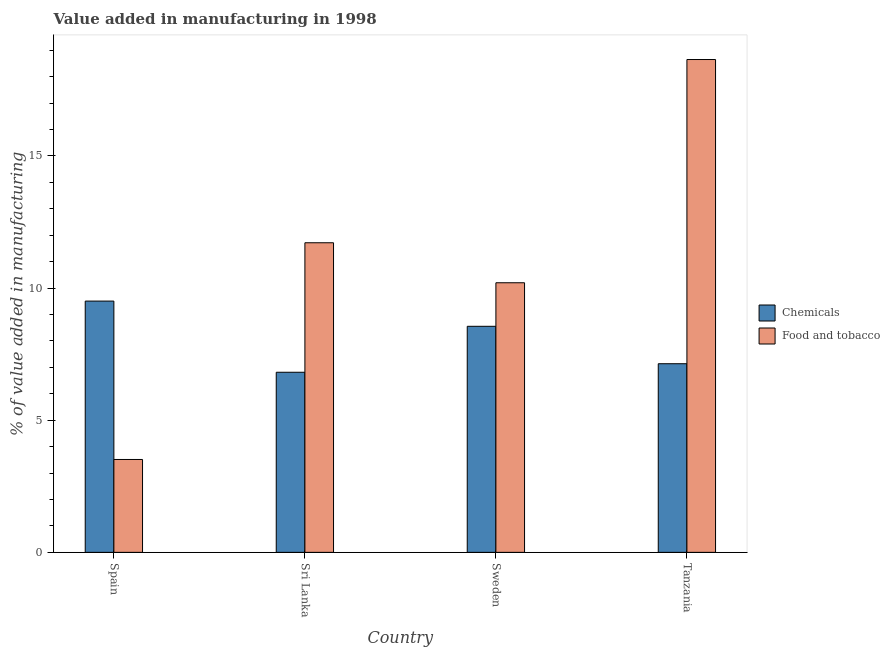How many different coloured bars are there?
Make the answer very short. 2. Are the number of bars per tick equal to the number of legend labels?
Offer a very short reply. Yes. How many bars are there on the 4th tick from the left?
Keep it short and to the point. 2. What is the label of the 3rd group of bars from the left?
Offer a terse response. Sweden. What is the value added by manufacturing food and tobacco in Tanzania?
Your response must be concise. 18.65. Across all countries, what is the maximum value added by manufacturing food and tobacco?
Provide a succinct answer. 18.65. Across all countries, what is the minimum value added by  manufacturing chemicals?
Provide a short and direct response. 6.81. In which country was the value added by  manufacturing chemicals maximum?
Offer a very short reply. Spain. In which country was the value added by  manufacturing chemicals minimum?
Make the answer very short. Sri Lanka. What is the total value added by  manufacturing chemicals in the graph?
Your answer should be compact. 32.01. What is the difference between the value added by manufacturing food and tobacco in Spain and that in Sweden?
Offer a terse response. -6.69. What is the difference between the value added by  manufacturing chemicals in Sweden and the value added by manufacturing food and tobacco in Tanzania?
Make the answer very short. -10.09. What is the average value added by  manufacturing chemicals per country?
Offer a terse response. 8. What is the difference between the value added by  manufacturing chemicals and value added by manufacturing food and tobacco in Tanzania?
Offer a terse response. -11.51. In how many countries, is the value added by  manufacturing chemicals greater than 14 %?
Make the answer very short. 0. What is the ratio of the value added by manufacturing food and tobacco in Sweden to that in Tanzania?
Ensure brevity in your answer.  0.55. Is the difference between the value added by manufacturing food and tobacco in Sweden and Tanzania greater than the difference between the value added by  manufacturing chemicals in Sweden and Tanzania?
Offer a terse response. No. What is the difference between the highest and the second highest value added by  manufacturing chemicals?
Provide a succinct answer. 0.95. What is the difference between the highest and the lowest value added by manufacturing food and tobacco?
Make the answer very short. 15.13. What does the 1st bar from the left in Sri Lanka represents?
Offer a very short reply. Chemicals. What does the 1st bar from the right in Sweden represents?
Your answer should be compact. Food and tobacco. How many bars are there?
Keep it short and to the point. 8. What is the difference between two consecutive major ticks on the Y-axis?
Keep it short and to the point. 5. Does the graph contain any zero values?
Provide a short and direct response. No. How many legend labels are there?
Your answer should be compact. 2. What is the title of the graph?
Ensure brevity in your answer.  Value added in manufacturing in 1998. What is the label or title of the Y-axis?
Provide a succinct answer. % of value added in manufacturing. What is the % of value added in manufacturing of Chemicals in Spain?
Your answer should be compact. 9.51. What is the % of value added in manufacturing in Food and tobacco in Spain?
Provide a succinct answer. 3.51. What is the % of value added in manufacturing of Chemicals in Sri Lanka?
Ensure brevity in your answer.  6.81. What is the % of value added in manufacturing in Food and tobacco in Sri Lanka?
Your answer should be compact. 11.71. What is the % of value added in manufacturing in Chemicals in Sweden?
Provide a short and direct response. 8.55. What is the % of value added in manufacturing of Food and tobacco in Sweden?
Ensure brevity in your answer.  10.2. What is the % of value added in manufacturing in Chemicals in Tanzania?
Your answer should be compact. 7.14. What is the % of value added in manufacturing of Food and tobacco in Tanzania?
Keep it short and to the point. 18.65. Across all countries, what is the maximum % of value added in manufacturing in Chemicals?
Offer a very short reply. 9.51. Across all countries, what is the maximum % of value added in manufacturing of Food and tobacco?
Your response must be concise. 18.65. Across all countries, what is the minimum % of value added in manufacturing of Chemicals?
Keep it short and to the point. 6.81. Across all countries, what is the minimum % of value added in manufacturing of Food and tobacco?
Keep it short and to the point. 3.51. What is the total % of value added in manufacturing of Chemicals in the graph?
Provide a short and direct response. 32.01. What is the total % of value added in manufacturing of Food and tobacco in the graph?
Your response must be concise. 44.08. What is the difference between the % of value added in manufacturing in Chemicals in Spain and that in Sri Lanka?
Provide a succinct answer. 2.69. What is the difference between the % of value added in manufacturing in Food and tobacco in Spain and that in Sri Lanka?
Your response must be concise. -8.2. What is the difference between the % of value added in manufacturing of Chemicals in Spain and that in Sweden?
Make the answer very short. 0.95. What is the difference between the % of value added in manufacturing of Food and tobacco in Spain and that in Sweden?
Your answer should be very brief. -6.69. What is the difference between the % of value added in manufacturing of Chemicals in Spain and that in Tanzania?
Offer a very short reply. 2.37. What is the difference between the % of value added in manufacturing in Food and tobacco in Spain and that in Tanzania?
Your answer should be very brief. -15.13. What is the difference between the % of value added in manufacturing of Chemicals in Sri Lanka and that in Sweden?
Offer a terse response. -1.74. What is the difference between the % of value added in manufacturing of Food and tobacco in Sri Lanka and that in Sweden?
Keep it short and to the point. 1.51. What is the difference between the % of value added in manufacturing in Chemicals in Sri Lanka and that in Tanzania?
Your answer should be very brief. -0.32. What is the difference between the % of value added in manufacturing of Food and tobacco in Sri Lanka and that in Tanzania?
Make the answer very short. -6.93. What is the difference between the % of value added in manufacturing of Chemicals in Sweden and that in Tanzania?
Provide a succinct answer. 1.42. What is the difference between the % of value added in manufacturing in Food and tobacco in Sweden and that in Tanzania?
Your response must be concise. -8.45. What is the difference between the % of value added in manufacturing of Chemicals in Spain and the % of value added in manufacturing of Food and tobacco in Sri Lanka?
Provide a short and direct response. -2.21. What is the difference between the % of value added in manufacturing of Chemicals in Spain and the % of value added in manufacturing of Food and tobacco in Sweden?
Make the answer very short. -0.69. What is the difference between the % of value added in manufacturing of Chemicals in Spain and the % of value added in manufacturing of Food and tobacco in Tanzania?
Your response must be concise. -9.14. What is the difference between the % of value added in manufacturing in Chemicals in Sri Lanka and the % of value added in manufacturing in Food and tobacco in Sweden?
Offer a terse response. -3.39. What is the difference between the % of value added in manufacturing of Chemicals in Sri Lanka and the % of value added in manufacturing of Food and tobacco in Tanzania?
Give a very brief answer. -11.83. What is the difference between the % of value added in manufacturing of Chemicals in Sweden and the % of value added in manufacturing of Food and tobacco in Tanzania?
Your response must be concise. -10.1. What is the average % of value added in manufacturing of Chemicals per country?
Give a very brief answer. 8. What is the average % of value added in manufacturing in Food and tobacco per country?
Give a very brief answer. 11.02. What is the difference between the % of value added in manufacturing of Chemicals and % of value added in manufacturing of Food and tobacco in Spain?
Keep it short and to the point. 5.99. What is the difference between the % of value added in manufacturing in Chemicals and % of value added in manufacturing in Food and tobacco in Sri Lanka?
Make the answer very short. -4.9. What is the difference between the % of value added in manufacturing of Chemicals and % of value added in manufacturing of Food and tobacco in Sweden?
Your response must be concise. -1.65. What is the difference between the % of value added in manufacturing of Chemicals and % of value added in manufacturing of Food and tobacco in Tanzania?
Provide a succinct answer. -11.51. What is the ratio of the % of value added in manufacturing of Chemicals in Spain to that in Sri Lanka?
Provide a succinct answer. 1.4. What is the ratio of the % of value added in manufacturing of Chemicals in Spain to that in Sweden?
Your answer should be compact. 1.11. What is the ratio of the % of value added in manufacturing of Food and tobacco in Spain to that in Sweden?
Provide a succinct answer. 0.34. What is the ratio of the % of value added in manufacturing in Chemicals in Spain to that in Tanzania?
Provide a short and direct response. 1.33. What is the ratio of the % of value added in manufacturing in Food and tobacco in Spain to that in Tanzania?
Give a very brief answer. 0.19. What is the ratio of the % of value added in manufacturing in Chemicals in Sri Lanka to that in Sweden?
Give a very brief answer. 0.8. What is the ratio of the % of value added in manufacturing of Food and tobacco in Sri Lanka to that in Sweden?
Your answer should be compact. 1.15. What is the ratio of the % of value added in manufacturing of Chemicals in Sri Lanka to that in Tanzania?
Offer a terse response. 0.95. What is the ratio of the % of value added in manufacturing of Food and tobacco in Sri Lanka to that in Tanzania?
Offer a very short reply. 0.63. What is the ratio of the % of value added in manufacturing in Chemicals in Sweden to that in Tanzania?
Your answer should be compact. 1.2. What is the ratio of the % of value added in manufacturing in Food and tobacco in Sweden to that in Tanzania?
Ensure brevity in your answer.  0.55. What is the difference between the highest and the second highest % of value added in manufacturing of Chemicals?
Provide a succinct answer. 0.95. What is the difference between the highest and the second highest % of value added in manufacturing of Food and tobacco?
Make the answer very short. 6.93. What is the difference between the highest and the lowest % of value added in manufacturing of Chemicals?
Your answer should be very brief. 2.69. What is the difference between the highest and the lowest % of value added in manufacturing in Food and tobacco?
Give a very brief answer. 15.13. 